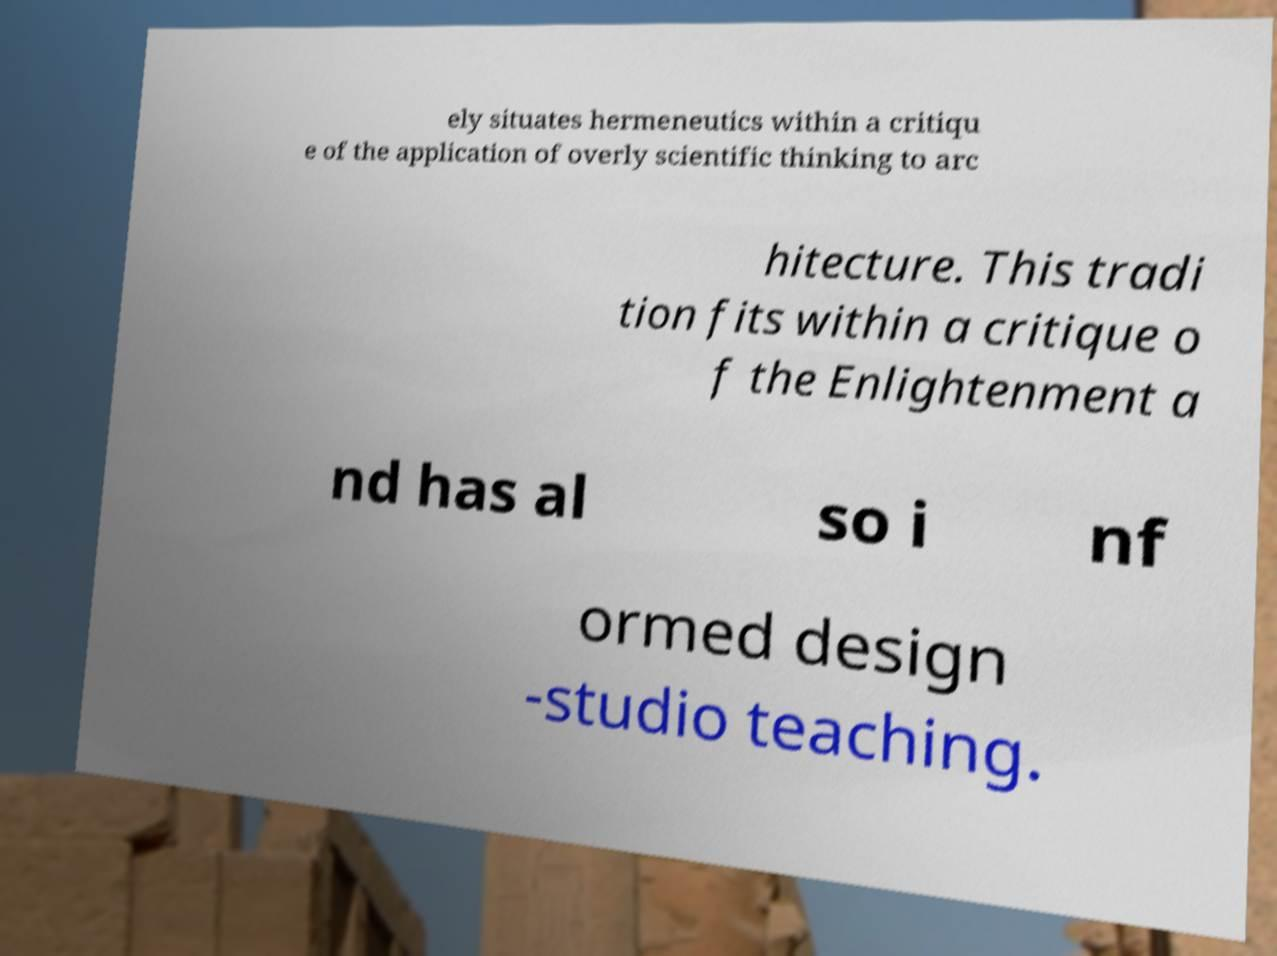I need the written content from this picture converted into text. Can you do that? ely situates hermeneutics within a critiqu e of the application of overly scientific thinking to arc hitecture. This tradi tion fits within a critique o f the Enlightenment a nd has al so i nf ormed design -studio teaching. 